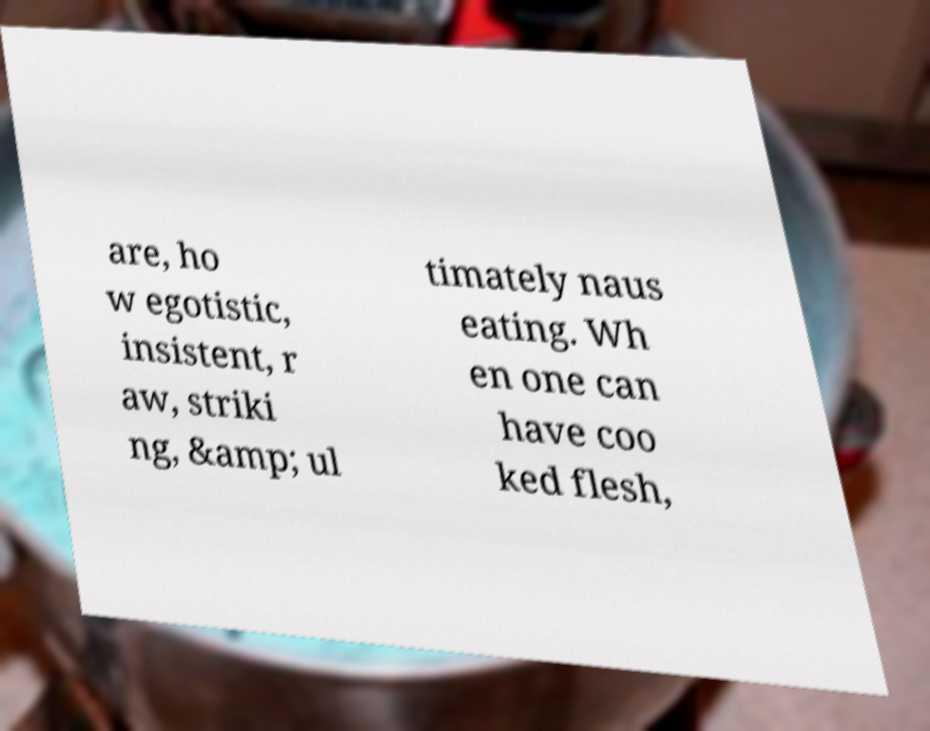Can you read and provide the text displayed in the image?This photo seems to have some interesting text. Can you extract and type it out for me? are, ho w egotistic, insistent, r aw, striki ng, &amp; ul timately naus eating. Wh en one can have coo ked flesh, 